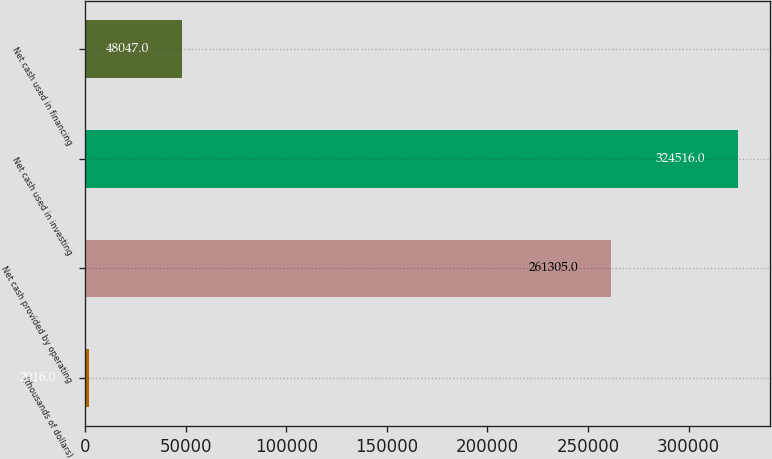Convert chart to OTSL. <chart><loc_0><loc_0><loc_500><loc_500><bar_chart><fcel>(thousands of dollars)<fcel>Net cash provided by operating<fcel>Net cash used in investing<fcel>Net cash used in financing<nl><fcel>2016<fcel>261305<fcel>324516<fcel>48047<nl></chart> 